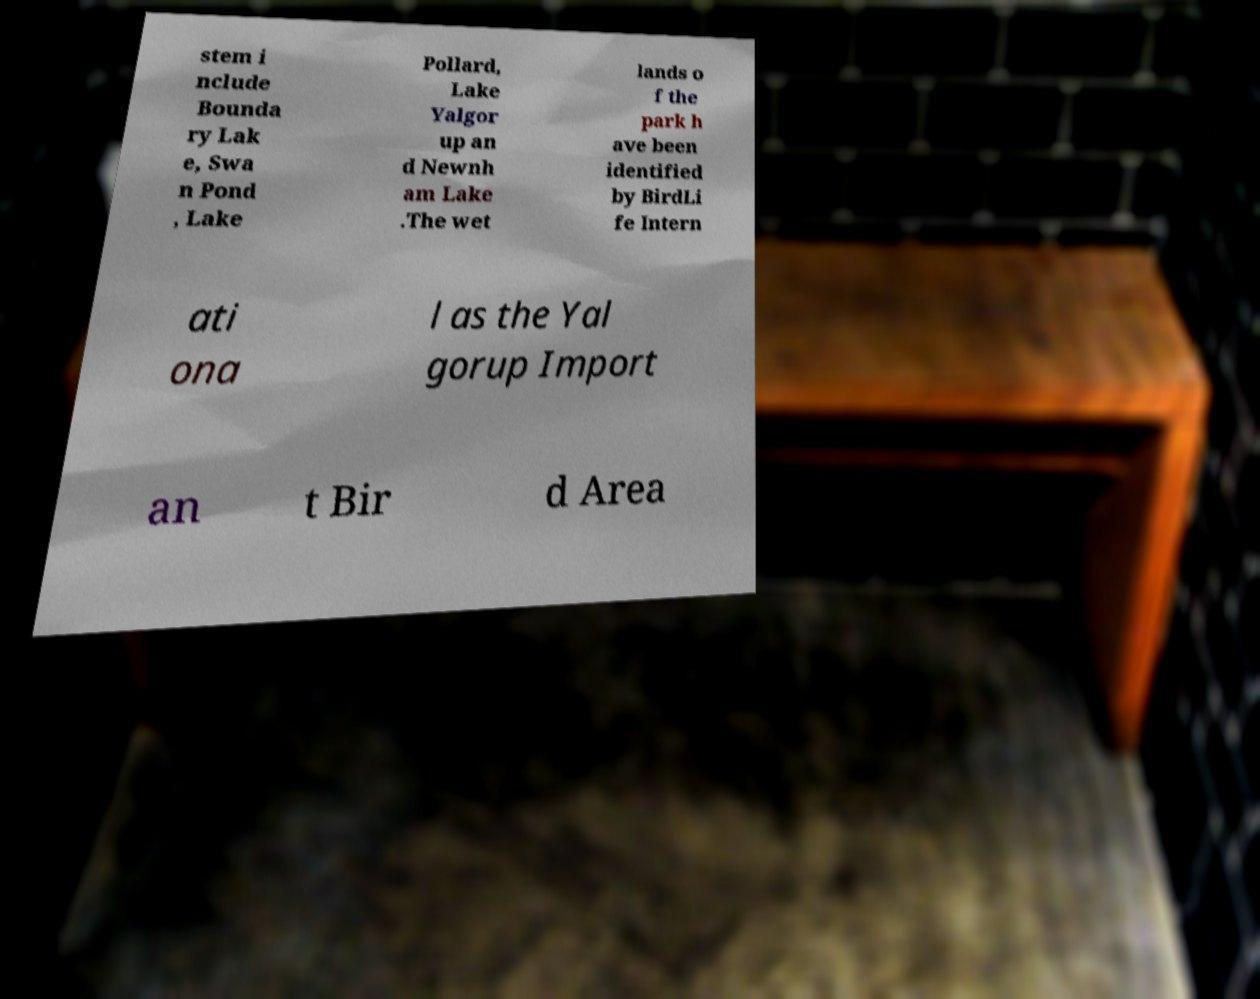I need the written content from this picture converted into text. Can you do that? stem i nclude Bounda ry Lak e, Swa n Pond , Lake Pollard, Lake Yalgor up an d Newnh am Lake .The wet lands o f the park h ave been identified by BirdLi fe Intern ati ona l as the Yal gorup Import an t Bir d Area 